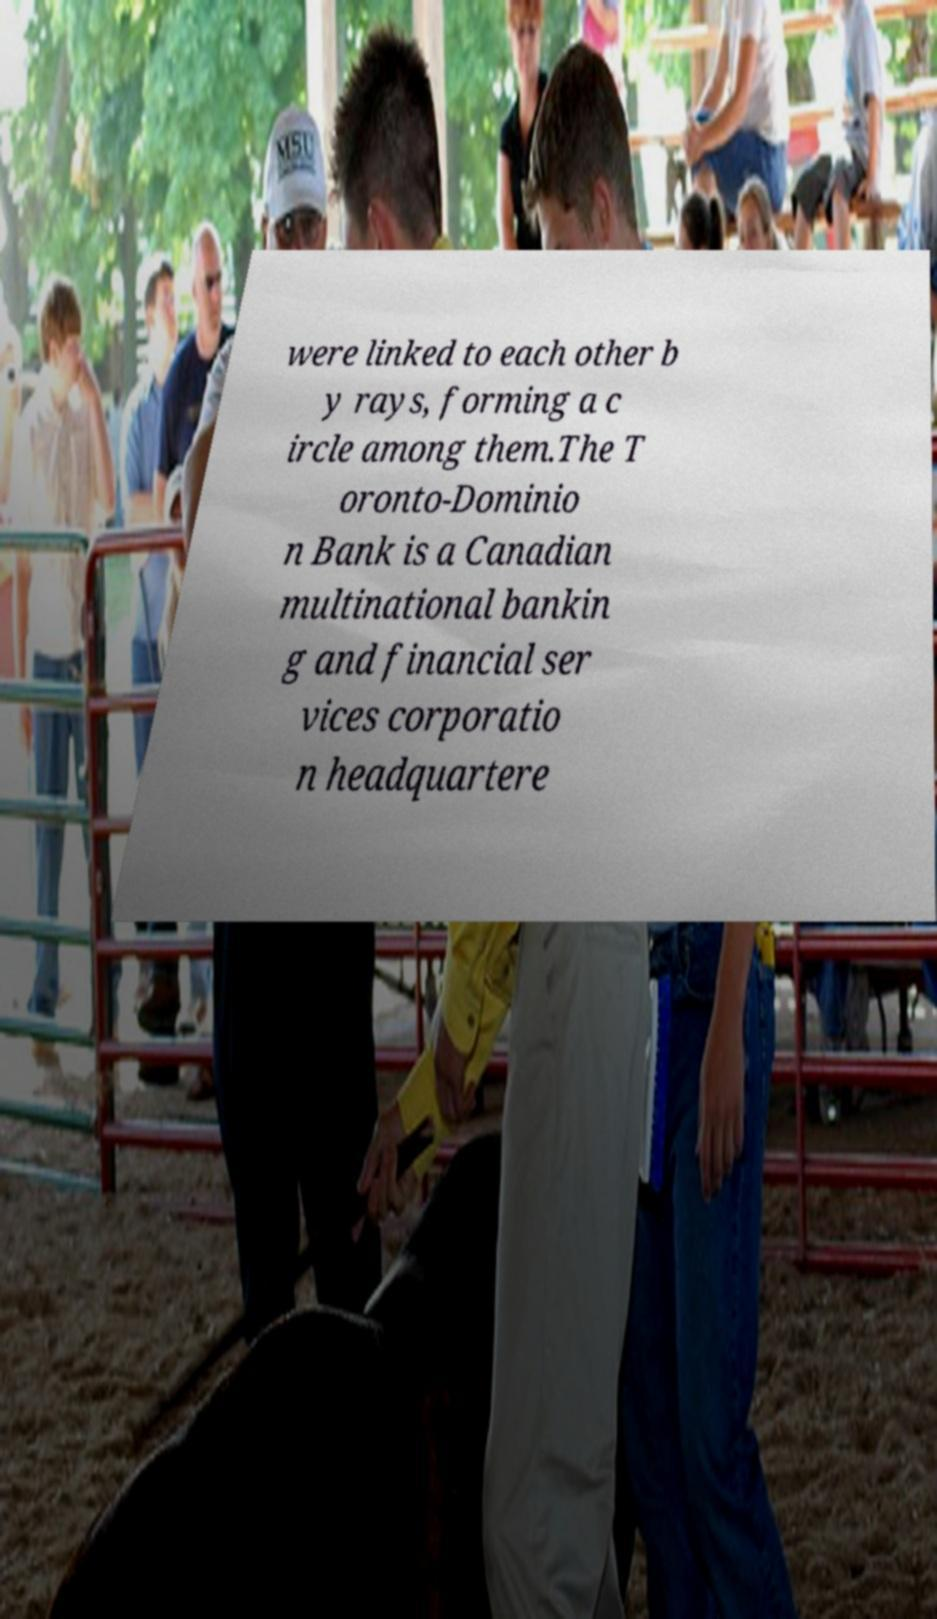What messages or text are displayed in this image? I need them in a readable, typed format. were linked to each other b y rays, forming a c ircle among them.The T oronto-Dominio n Bank is a Canadian multinational bankin g and financial ser vices corporatio n headquartere 